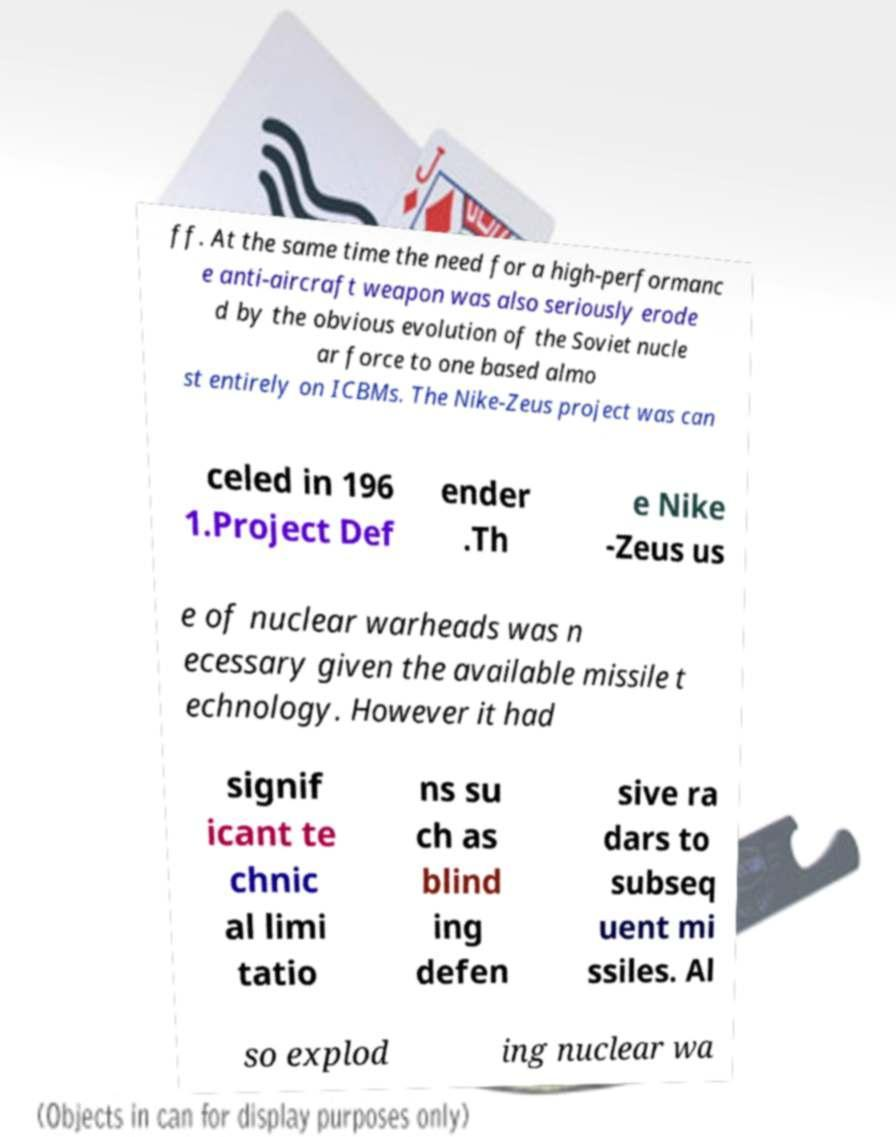There's text embedded in this image that I need extracted. Can you transcribe it verbatim? ff. At the same time the need for a high-performanc e anti-aircraft weapon was also seriously erode d by the obvious evolution of the Soviet nucle ar force to one based almo st entirely on ICBMs. The Nike-Zeus project was can celed in 196 1.Project Def ender .Th e Nike -Zeus us e of nuclear warheads was n ecessary given the available missile t echnology. However it had signif icant te chnic al limi tatio ns su ch as blind ing defen sive ra dars to subseq uent mi ssiles. Al so explod ing nuclear wa 